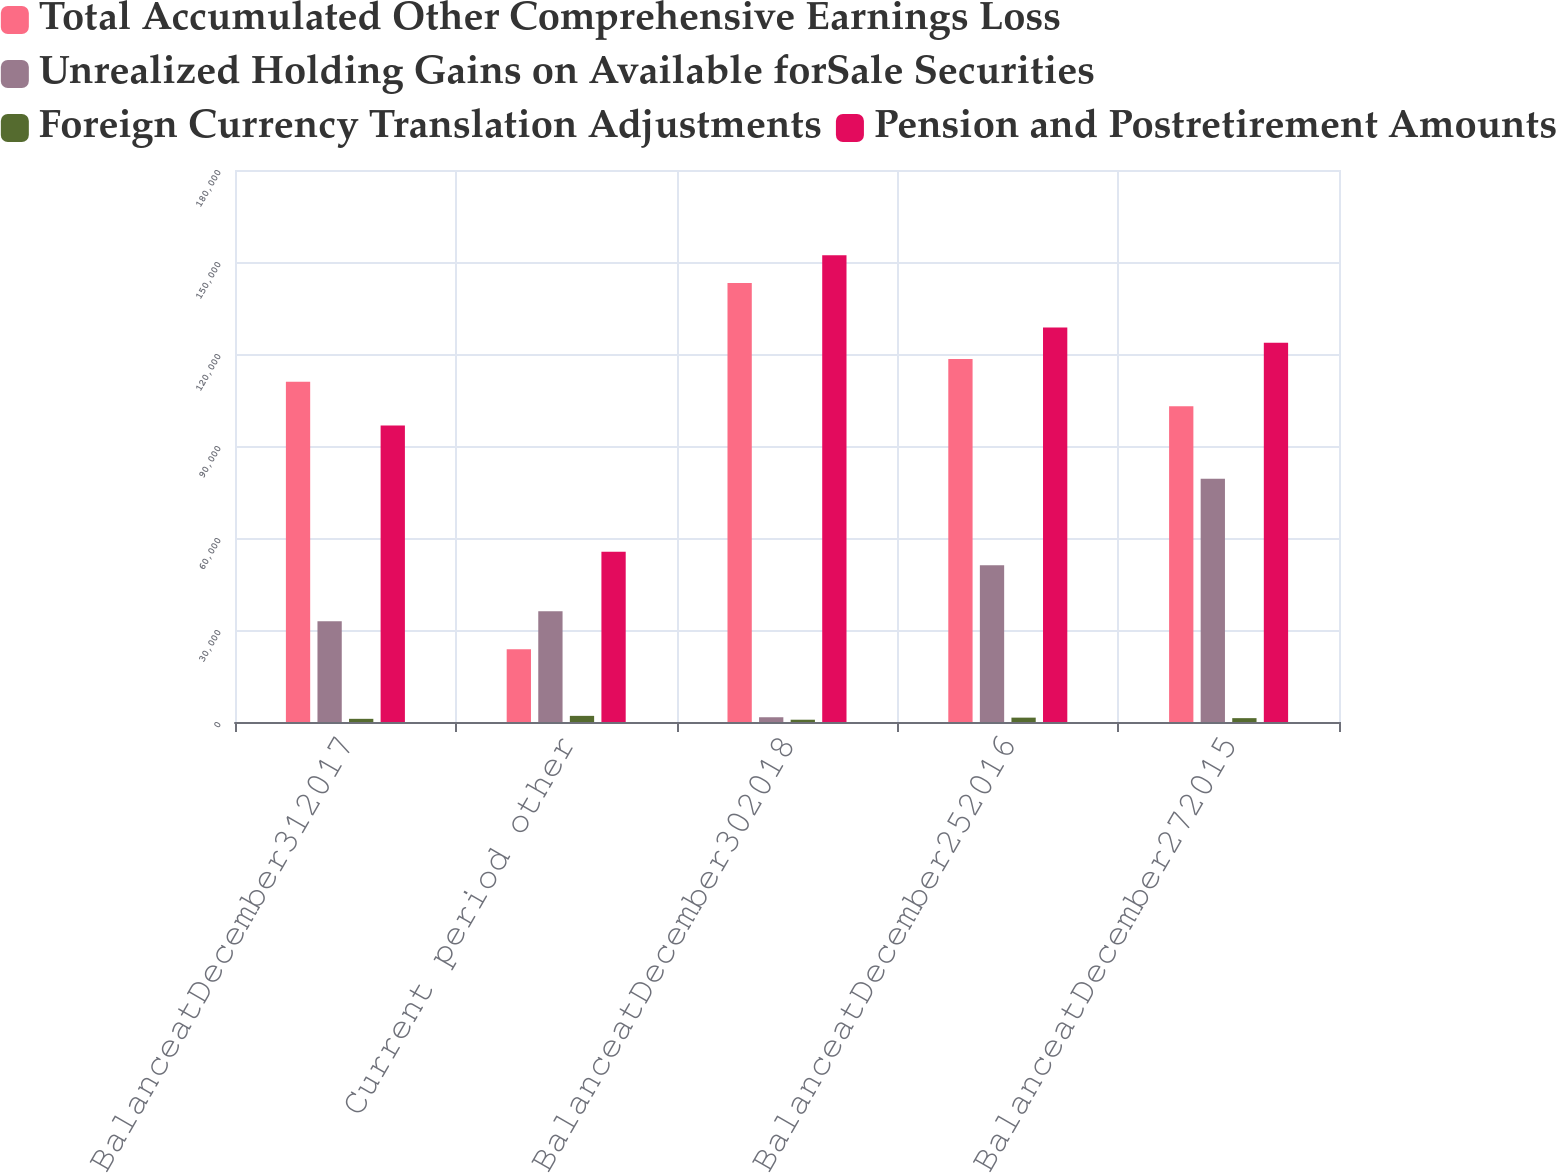Convert chart. <chart><loc_0><loc_0><loc_500><loc_500><stacked_bar_chart><ecel><fcel>BalanceatDecember312017<fcel>Current period other<fcel>BalanceatDecember302018<fcel>BalanceatDecember252016<fcel>BalanceatDecember272015<nl><fcel>Total Accumulated Other Comprehensive Earnings Loss<fcel>110971<fcel>23763<fcel>143134<fcel>118401<fcel>102931<nl><fcel>Unrealized Holding Gains on Available forSale Securities<fcel>32827<fcel>36107<fcel>1549<fcel>51085<fcel>79317<nl><fcel>Foreign Currency Translation Adjustments<fcel>1034<fcel>2000<fcel>744<fcel>1424<fcel>1258<nl><fcel>Pension and Postretirement Amounts<fcel>96661<fcel>55524<fcel>152185<fcel>128678<fcel>123645<nl></chart> 